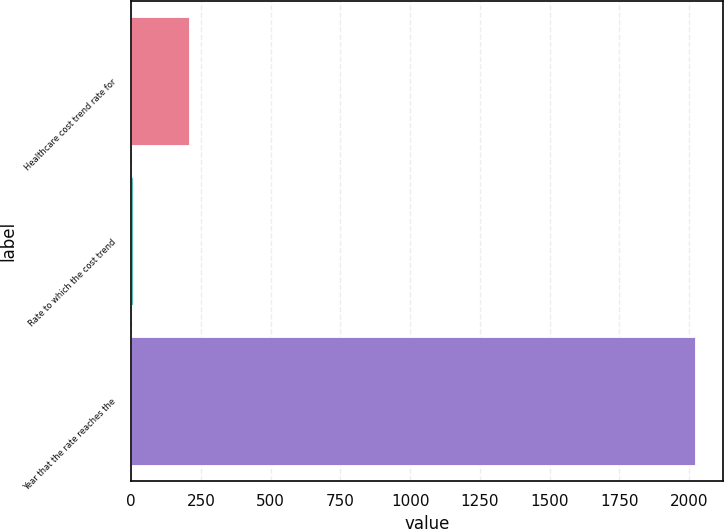Convert chart to OTSL. <chart><loc_0><loc_0><loc_500><loc_500><bar_chart><fcel>Healthcare cost trend rate for<fcel>Rate to which the cost trend<fcel>Year that the rate reaches the<nl><fcel>206.6<fcel>5<fcel>2021<nl></chart> 